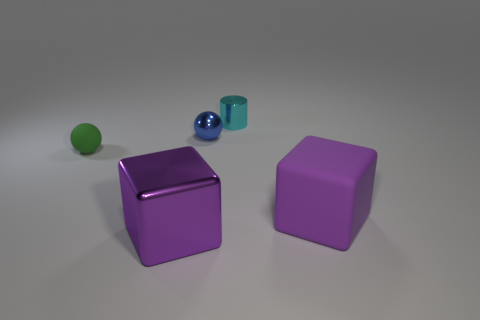Is the color of the cube on the left side of the tiny cyan thing the same as the matte sphere?
Provide a short and direct response. No. There is a cube to the right of the large purple block that is in front of the purple matte object; how big is it?
Your answer should be very brief. Large. What is the material of the green object that is the same size as the shiny ball?
Make the answer very short. Rubber. How many other things are the same size as the purple metallic object?
Your response must be concise. 1. How many balls are large purple matte objects or cyan shiny objects?
Provide a succinct answer. 0. Are there any other things that have the same material as the cyan thing?
Offer a very short reply. Yes. The small ball that is to the left of the purple thing to the left of the small ball behind the green ball is made of what material?
Keep it short and to the point. Rubber. There is another large block that is the same color as the metal block; what is its material?
Your answer should be compact. Rubber. What number of small brown spheres have the same material as the small blue ball?
Provide a succinct answer. 0. There is a metallic object in front of the green matte ball; is its size the same as the small blue ball?
Provide a succinct answer. No. 